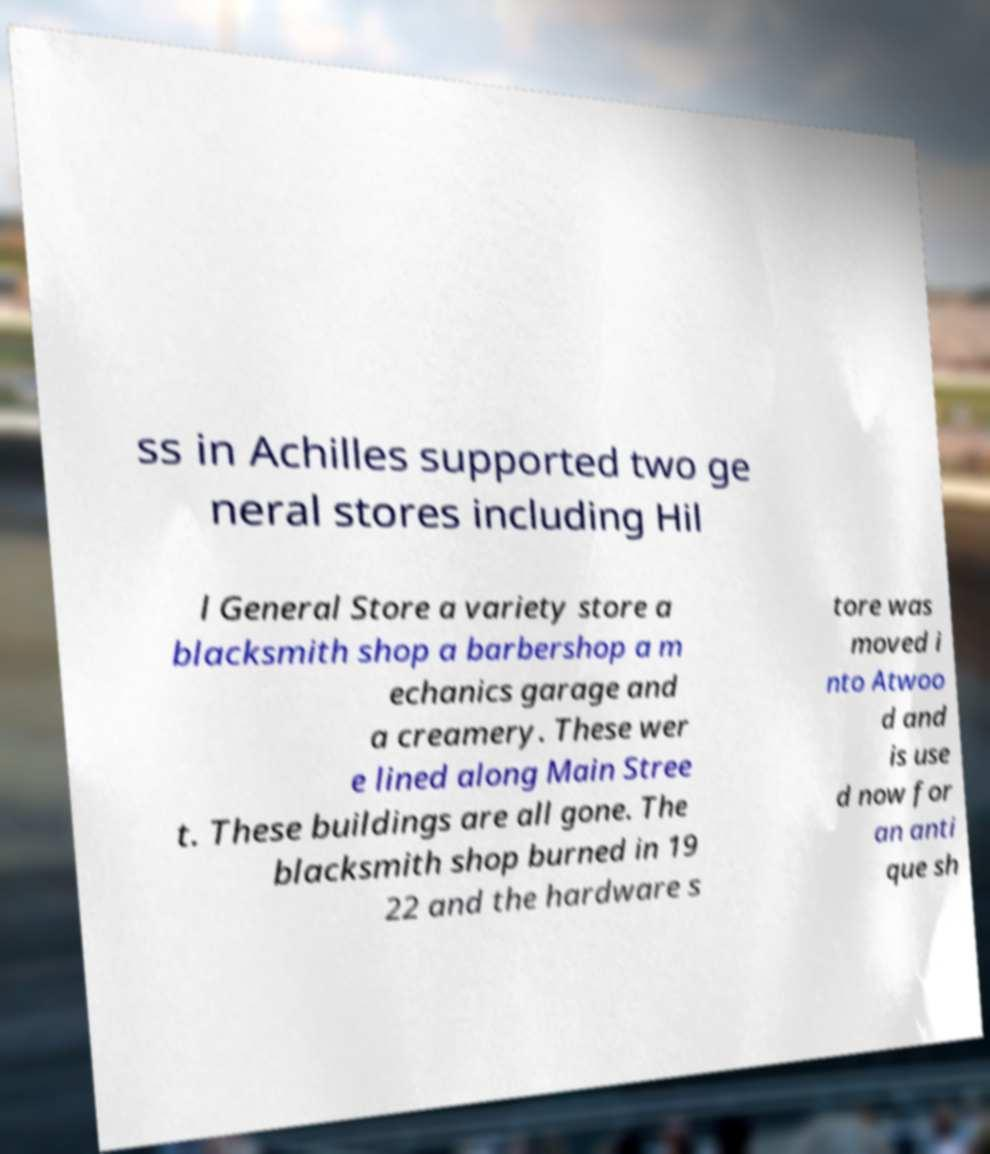Could you assist in decoding the text presented in this image and type it out clearly? ss in Achilles supported two ge neral stores including Hil l General Store a variety store a blacksmith shop a barbershop a m echanics garage and a creamery. These wer e lined along Main Stree t. These buildings are all gone. The blacksmith shop burned in 19 22 and the hardware s tore was moved i nto Atwoo d and is use d now for an anti que sh 